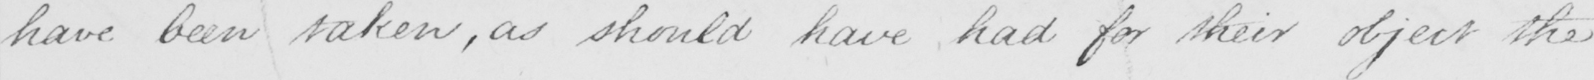Can you tell me what this handwritten text says? have been taken , as should have had for their object the 